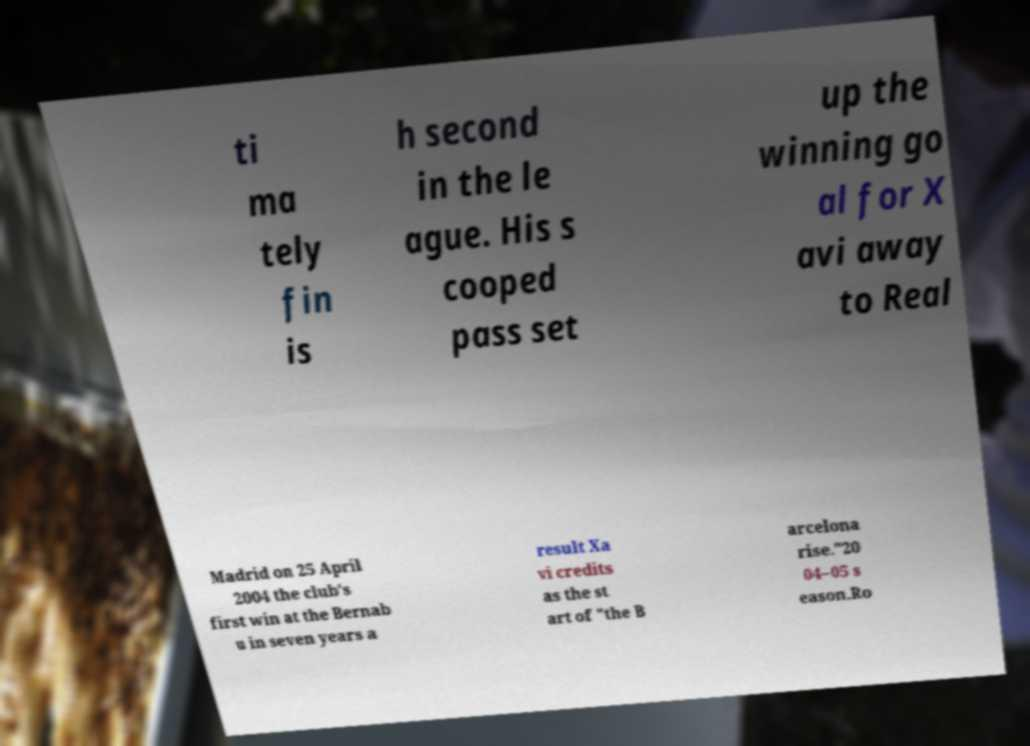Could you assist in decoding the text presented in this image and type it out clearly? ti ma tely fin is h second in the le ague. His s cooped pass set up the winning go al for X avi away to Real Madrid on 25 April 2004 the club's first win at the Bernab u in seven years a result Xa vi credits as the st art of "the B arcelona rise."20 04–05 s eason.Ro 